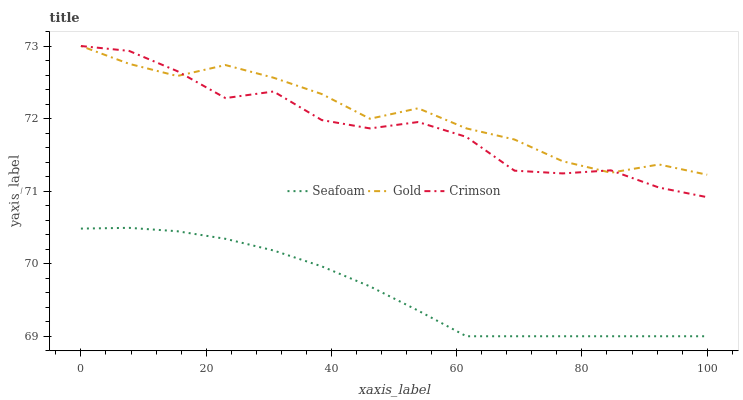Does Seafoam have the minimum area under the curve?
Answer yes or no. Yes. Does Gold have the maximum area under the curve?
Answer yes or no. Yes. Does Gold have the minimum area under the curve?
Answer yes or no. No. Does Seafoam have the maximum area under the curve?
Answer yes or no. No. Is Seafoam the smoothest?
Answer yes or no. Yes. Is Crimson the roughest?
Answer yes or no. Yes. Is Gold the smoothest?
Answer yes or no. No. Is Gold the roughest?
Answer yes or no. No. Does Seafoam have the lowest value?
Answer yes or no. Yes. Does Gold have the lowest value?
Answer yes or no. No. Does Gold have the highest value?
Answer yes or no. Yes. Does Seafoam have the highest value?
Answer yes or no. No. Is Seafoam less than Gold?
Answer yes or no. Yes. Is Crimson greater than Seafoam?
Answer yes or no. Yes. Does Crimson intersect Gold?
Answer yes or no. Yes. Is Crimson less than Gold?
Answer yes or no. No. Is Crimson greater than Gold?
Answer yes or no. No. Does Seafoam intersect Gold?
Answer yes or no. No. 